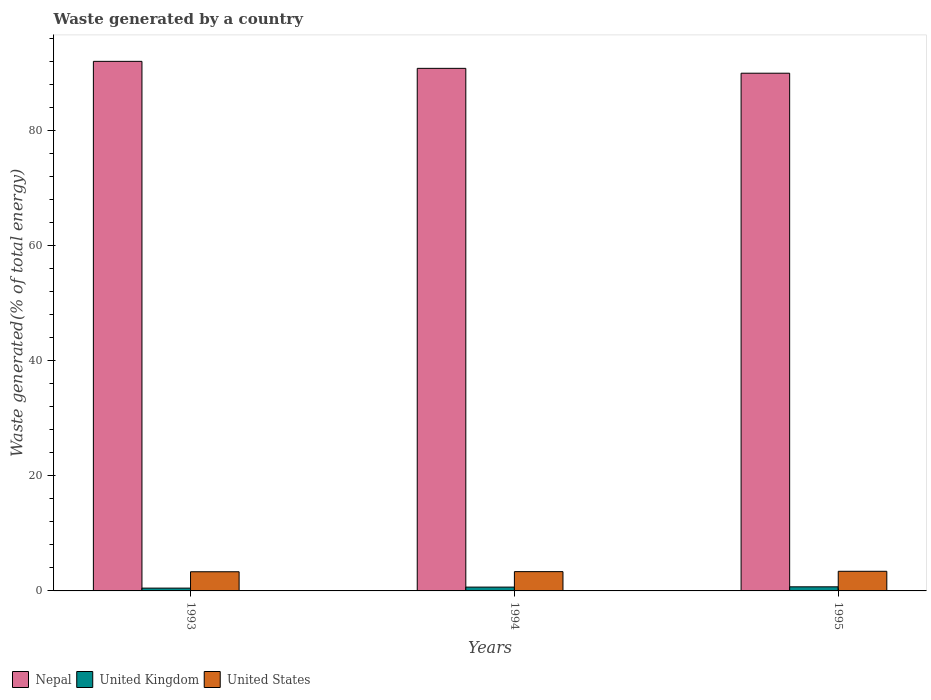How many different coloured bars are there?
Give a very brief answer. 3. How many groups of bars are there?
Your response must be concise. 3. Are the number of bars on each tick of the X-axis equal?
Make the answer very short. Yes. How many bars are there on the 3rd tick from the left?
Your answer should be very brief. 3. What is the label of the 1st group of bars from the left?
Your response must be concise. 1993. What is the total waste generated in Nepal in 1995?
Make the answer very short. 89.97. Across all years, what is the maximum total waste generated in United States?
Your answer should be very brief. 3.41. Across all years, what is the minimum total waste generated in United States?
Your answer should be compact. 3.33. What is the total total waste generated in United Kingdom in the graph?
Offer a very short reply. 1.86. What is the difference between the total waste generated in United Kingdom in 1994 and that in 1995?
Offer a terse response. -0.05. What is the difference between the total waste generated in United States in 1994 and the total waste generated in Nepal in 1995?
Provide a succinct answer. -86.62. What is the average total waste generated in United States per year?
Provide a short and direct response. 3.36. In the year 1993, what is the difference between the total waste generated in Nepal and total waste generated in United Kingdom?
Your answer should be very brief. 91.55. In how many years, is the total waste generated in United States greater than 76 %?
Your answer should be very brief. 0. What is the ratio of the total waste generated in United Kingdom in 1993 to that in 1994?
Ensure brevity in your answer.  0.73. Is the total waste generated in United Kingdom in 1994 less than that in 1995?
Give a very brief answer. Yes. Is the difference between the total waste generated in Nepal in 1993 and 1995 greater than the difference between the total waste generated in United Kingdom in 1993 and 1995?
Offer a very short reply. Yes. What is the difference between the highest and the second highest total waste generated in United States?
Make the answer very short. 0.06. What is the difference between the highest and the lowest total waste generated in United States?
Provide a short and direct response. 0.08. In how many years, is the total waste generated in United States greater than the average total waste generated in United States taken over all years?
Give a very brief answer. 1. Is the sum of the total waste generated in United Kingdom in 1993 and 1995 greater than the maximum total waste generated in United States across all years?
Your answer should be very brief. No. What does the 3rd bar from the left in 1994 represents?
Provide a short and direct response. United States. Are all the bars in the graph horizontal?
Your answer should be very brief. No. What is the difference between two consecutive major ticks on the Y-axis?
Give a very brief answer. 20. Are the values on the major ticks of Y-axis written in scientific E-notation?
Give a very brief answer. No. How are the legend labels stacked?
Provide a succinct answer. Horizontal. What is the title of the graph?
Offer a terse response. Waste generated by a country. Does "Tanzania" appear as one of the legend labels in the graph?
Your response must be concise. No. What is the label or title of the X-axis?
Offer a very short reply. Years. What is the label or title of the Y-axis?
Keep it short and to the point. Waste generated(% of total energy). What is the Waste generated(% of total energy) in Nepal in 1993?
Ensure brevity in your answer.  92.04. What is the Waste generated(% of total energy) of United Kingdom in 1993?
Keep it short and to the point. 0.49. What is the Waste generated(% of total energy) of United States in 1993?
Make the answer very short. 3.33. What is the Waste generated(% of total energy) in Nepal in 1994?
Provide a succinct answer. 90.82. What is the Waste generated(% of total energy) of United Kingdom in 1994?
Make the answer very short. 0.66. What is the Waste generated(% of total energy) in United States in 1994?
Provide a short and direct response. 3.35. What is the Waste generated(% of total energy) of Nepal in 1995?
Keep it short and to the point. 89.97. What is the Waste generated(% of total energy) of United Kingdom in 1995?
Keep it short and to the point. 0.71. What is the Waste generated(% of total energy) in United States in 1995?
Provide a short and direct response. 3.41. Across all years, what is the maximum Waste generated(% of total energy) of Nepal?
Offer a terse response. 92.04. Across all years, what is the maximum Waste generated(% of total energy) in United Kingdom?
Offer a terse response. 0.71. Across all years, what is the maximum Waste generated(% of total energy) of United States?
Ensure brevity in your answer.  3.41. Across all years, what is the minimum Waste generated(% of total energy) in Nepal?
Keep it short and to the point. 89.97. Across all years, what is the minimum Waste generated(% of total energy) in United Kingdom?
Your answer should be very brief. 0.49. Across all years, what is the minimum Waste generated(% of total energy) of United States?
Your response must be concise. 3.33. What is the total Waste generated(% of total energy) in Nepal in the graph?
Your response must be concise. 272.83. What is the total Waste generated(% of total energy) in United Kingdom in the graph?
Your answer should be compact. 1.86. What is the total Waste generated(% of total energy) of United States in the graph?
Offer a terse response. 10.09. What is the difference between the Waste generated(% of total energy) of Nepal in 1993 and that in 1994?
Your response must be concise. 1.22. What is the difference between the Waste generated(% of total energy) of United Kingdom in 1993 and that in 1994?
Offer a terse response. -0.18. What is the difference between the Waste generated(% of total energy) in United States in 1993 and that in 1994?
Provide a succinct answer. -0.02. What is the difference between the Waste generated(% of total energy) in Nepal in 1993 and that in 1995?
Your answer should be very brief. 2.06. What is the difference between the Waste generated(% of total energy) in United Kingdom in 1993 and that in 1995?
Provide a short and direct response. -0.22. What is the difference between the Waste generated(% of total energy) of United States in 1993 and that in 1995?
Your answer should be compact. -0.08. What is the difference between the Waste generated(% of total energy) in Nepal in 1994 and that in 1995?
Give a very brief answer. 0.84. What is the difference between the Waste generated(% of total energy) of United Kingdom in 1994 and that in 1995?
Offer a terse response. -0.05. What is the difference between the Waste generated(% of total energy) of United States in 1994 and that in 1995?
Provide a short and direct response. -0.06. What is the difference between the Waste generated(% of total energy) in Nepal in 1993 and the Waste generated(% of total energy) in United Kingdom in 1994?
Ensure brevity in your answer.  91.37. What is the difference between the Waste generated(% of total energy) of Nepal in 1993 and the Waste generated(% of total energy) of United States in 1994?
Offer a terse response. 88.68. What is the difference between the Waste generated(% of total energy) of United Kingdom in 1993 and the Waste generated(% of total energy) of United States in 1994?
Your answer should be compact. -2.86. What is the difference between the Waste generated(% of total energy) in Nepal in 1993 and the Waste generated(% of total energy) in United Kingdom in 1995?
Provide a short and direct response. 91.32. What is the difference between the Waste generated(% of total energy) in Nepal in 1993 and the Waste generated(% of total energy) in United States in 1995?
Offer a very short reply. 88.62. What is the difference between the Waste generated(% of total energy) of United Kingdom in 1993 and the Waste generated(% of total energy) of United States in 1995?
Give a very brief answer. -2.92. What is the difference between the Waste generated(% of total energy) of Nepal in 1994 and the Waste generated(% of total energy) of United Kingdom in 1995?
Your answer should be compact. 90.11. What is the difference between the Waste generated(% of total energy) of Nepal in 1994 and the Waste generated(% of total energy) of United States in 1995?
Give a very brief answer. 87.41. What is the difference between the Waste generated(% of total energy) in United Kingdom in 1994 and the Waste generated(% of total energy) in United States in 1995?
Keep it short and to the point. -2.75. What is the average Waste generated(% of total energy) in Nepal per year?
Offer a very short reply. 90.94. What is the average Waste generated(% of total energy) of United Kingdom per year?
Give a very brief answer. 0.62. What is the average Waste generated(% of total energy) in United States per year?
Keep it short and to the point. 3.37. In the year 1993, what is the difference between the Waste generated(% of total energy) in Nepal and Waste generated(% of total energy) in United Kingdom?
Ensure brevity in your answer.  91.55. In the year 1993, what is the difference between the Waste generated(% of total energy) in Nepal and Waste generated(% of total energy) in United States?
Provide a short and direct response. 88.7. In the year 1993, what is the difference between the Waste generated(% of total energy) in United Kingdom and Waste generated(% of total energy) in United States?
Provide a short and direct response. -2.84. In the year 1994, what is the difference between the Waste generated(% of total energy) of Nepal and Waste generated(% of total energy) of United Kingdom?
Provide a succinct answer. 90.16. In the year 1994, what is the difference between the Waste generated(% of total energy) of Nepal and Waste generated(% of total energy) of United States?
Provide a short and direct response. 87.47. In the year 1994, what is the difference between the Waste generated(% of total energy) of United Kingdom and Waste generated(% of total energy) of United States?
Keep it short and to the point. -2.69. In the year 1995, what is the difference between the Waste generated(% of total energy) in Nepal and Waste generated(% of total energy) in United Kingdom?
Ensure brevity in your answer.  89.26. In the year 1995, what is the difference between the Waste generated(% of total energy) of Nepal and Waste generated(% of total energy) of United States?
Provide a short and direct response. 86.56. What is the ratio of the Waste generated(% of total energy) in Nepal in 1993 to that in 1994?
Give a very brief answer. 1.01. What is the ratio of the Waste generated(% of total energy) in United Kingdom in 1993 to that in 1994?
Offer a terse response. 0.73. What is the ratio of the Waste generated(% of total energy) of Nepal in 1993 to that in 1995?
Keep it short and to the point. 1.02. What is the ratio of the Waste generated(% of total energy) in United Kingdom in 1993 to that in 1995?
Give a very brief answer. 0.69. What is the ratio of the Waste generated(% of total energy) of United States in 1993 to that in 1995?
Ensure brevity in your answer.  0.98. What is the ratio of the Waste generated(% of total energy) of Nepal in 1994 to that in 1995?
Provide a short and direct response. 1.01. What is the ratio of the Waste generated(% of total energy) of United Kingdom in 1994 to that in 1995?
Your answer should be very brief. 0.93. What is the ratio of the Waste generated(% of total energy) of United States in 1994 to that in 1995?
Keep it short and to the point. 0.98. What is the difference between the highest and the second highest Waste generated(% of total energy) in Nepal?
Offer a very short reply. 1.22. What is the difference between the highest and the second highest Waste generated(% of total energy) of United Kingdom?
Ensure brevity in your answer.  0.05. What is the difference between the highest and the second highest Waste generated(% of total energy) in United States?
Keep it short and to the point. 0.06. What is the difference between the highest and the lowest Waste generated(% of total energy) in Nepal?
Provide a succinct answer. 2.06. What is the difference between the highest and the lowest Waste generated(% of total energy) in United Kingdom?
Provide a succinct answer. 0.22. What is the difference between the highest and the lowest Waste generated(% of total energy) of United States?
Your response must be concise. 0.08. 